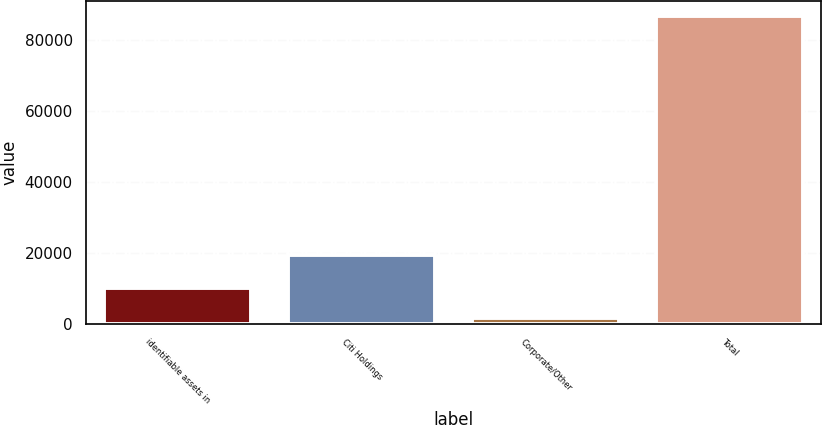<chart> <loc_0><loc_0><loc_500><loc_500><bar_chart><fcel>identifiable assets in<fcel>Citi Holdings<fcel>Corporate/Other<fcel>Total<nl><fcel>10238.7<fcel>19287<fcel>1754<fcel>86601<nl></chart> 